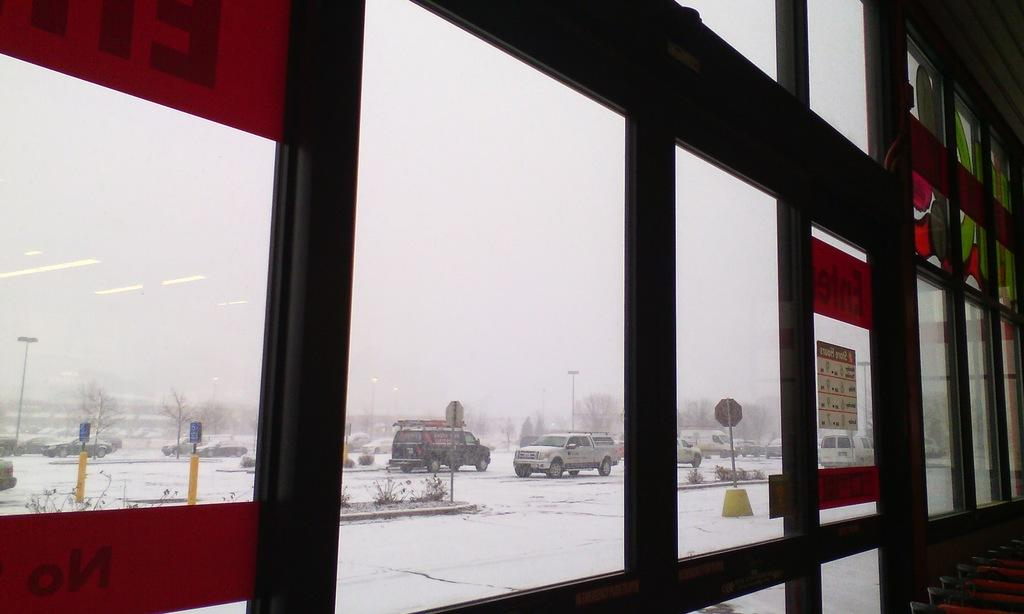What is located in the center of the image? There is a glass and roof in the center of the image. What can be seen through the glass? The sky, clouds, sign boards, plants, and few vehicles are visible through the glass. Can you see a park or a balloon through the glass in the image? No, there is no park or balloon visible through the glass in the image. Is there an event taking place in the image? The provided facts do not mention any event taking place in the image. 